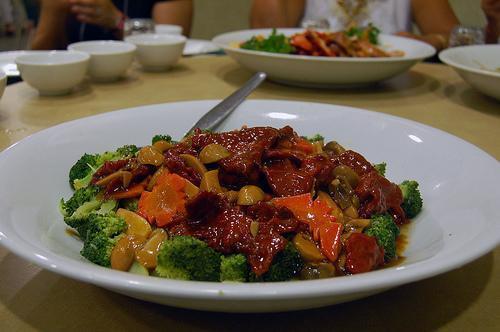How many utensils are shown?
Give a very brief answer. 1. How many plates with stir fried food are on the table?
Give a very brief answer. 2. How many colors do the plates have?
Give a very brief answer. 1. How many small bowls are there?
Give a very brief answer. 3. How many small bowls are on the table?
Give a very brief answer. 3. How many bowls contain food?
Give a very brief answer. 2. How many people are in the background?
Give a very brief answer. 2. How many small bowls are in front of the woman in blue?
Give a very brief answer. 3. How many forks are on the plate?
Give a very brief answer. 1. How many utensils do you see?
Give a very brief answer. 1. How many people can you see?
Give a very brief answer. 2. How many broccolis are in the picture?
Give a very brief answer. 3. How many bowls are in the picture?
Give a very brief answer. 3. How many black donut are there this images?
Give a very brief answer. 0. 